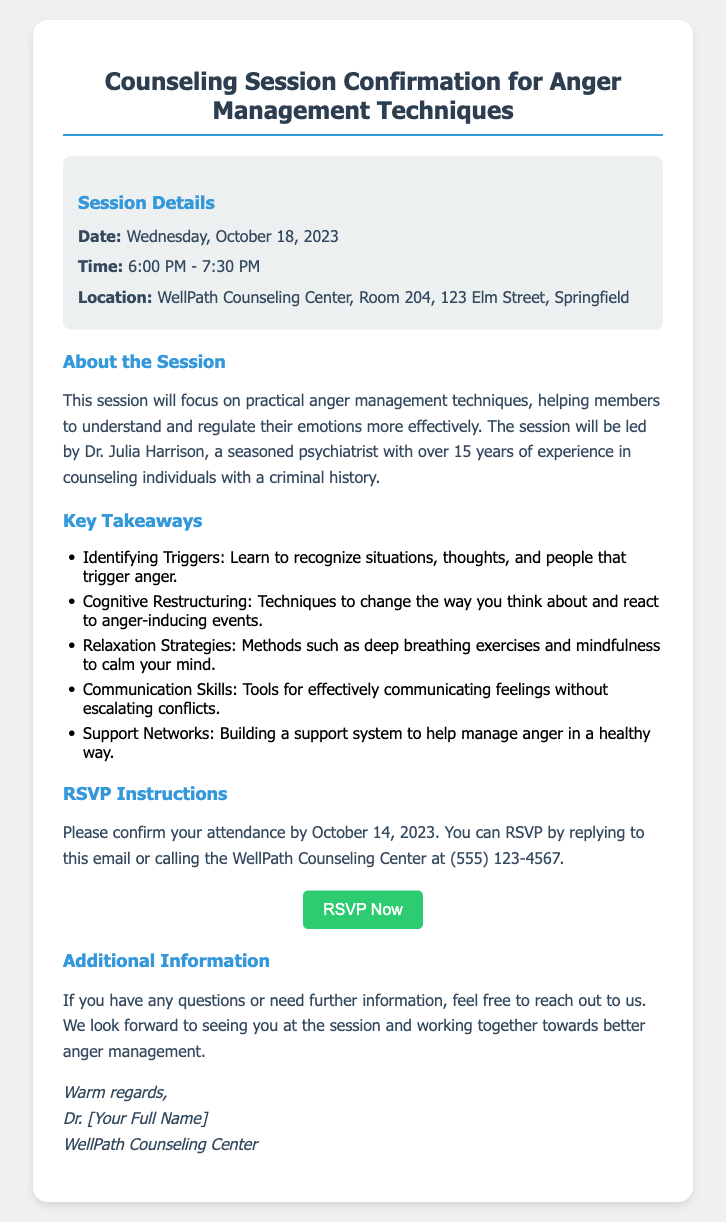What is the date of the session? The date of the session is specified in the document under the session details as Wednesday, October 18, 2023.
Answer: Wednesday, October 18, 2023 What are the session timings? The session timings are listed in the session details section, indicating it starts at 6:00 PM and ends at 7:30 PM.
Answer: 6:00 PM - 7:30 PM Where is the session located? The location of the session is provided in the document, specifying WellPath Counseling Center, Room 204, 123 Elm Street, Springfield.
Answer: WellPath Counseling Center, Room 204, 123 Elm Street, Springfield Who is leading the session? The document mentions that Dr. Julia Harrison is leading the session, providing her name in the about section.
Answer: Dr. Julia Harrison What is one key takeaway from the session? The document lists several key takeaways, such as learning to recognize situations that trigger anger listed in the bullet points.
Answer: Identifying Triggers By when should I confirm my attendance? The RSVP instructions indicate a deadline for confirmation of attendance by October 14, 2023.
Answer: October 14, 2023 How can I RSVP? The RSVP instructions provide two options for confirming attendance, by replying to the email or calling the counseling center.
Answer: Replying to this email or calling What is the purpose of the session? The document describes the purpose of the session as focusing on practical anger management techniques.
Answer: Practical anger management techniques What type of professionals attend the session? The document states that the session is focused on individuals with a criminal history, indicating that attendees are likely sharing similar backgrounds.
Answer: Individuals with a criminal history 